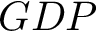Convert formula to latex. <formula><loc_0><loc_0><loc_500><loc_500>G D P</formula> 